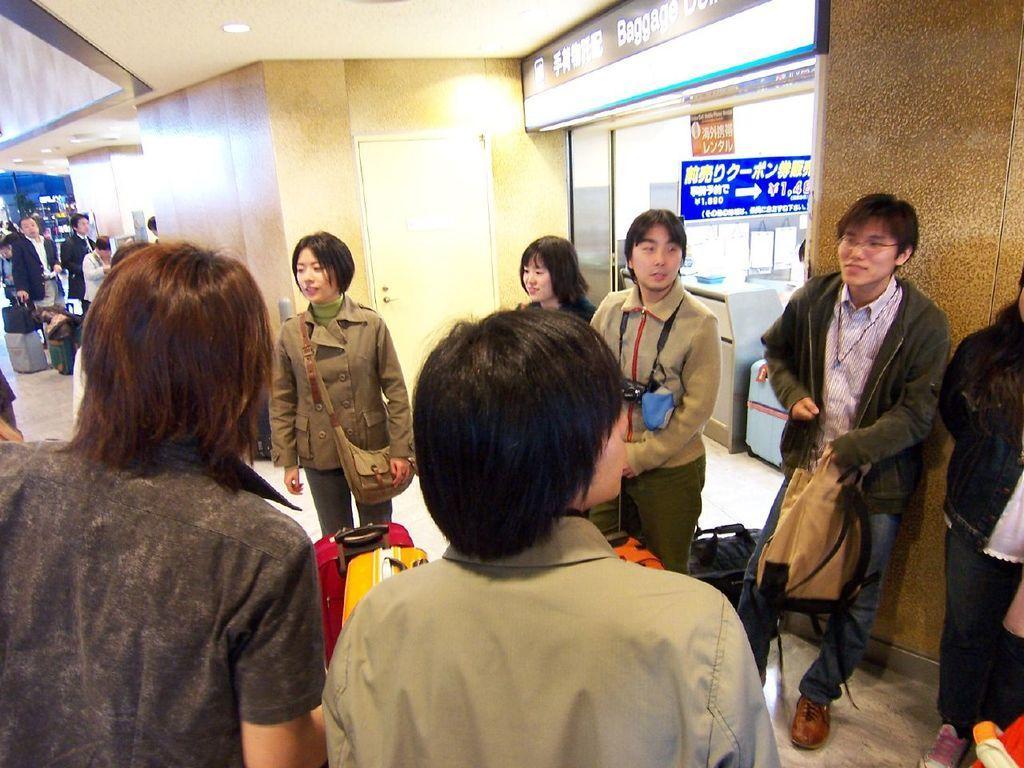Could you give a brief overview of what you see in this image? Here in this picture we can see a group of people standing over a place and in front of them we can see luggage bags and some of them are carrying the bags and the person in the middle is carrying a camera with him and behind them we can see a store with hoarding present on it and on the left side we can also see other people standing in a line with luggage with them and on the roof we can see lights present. 